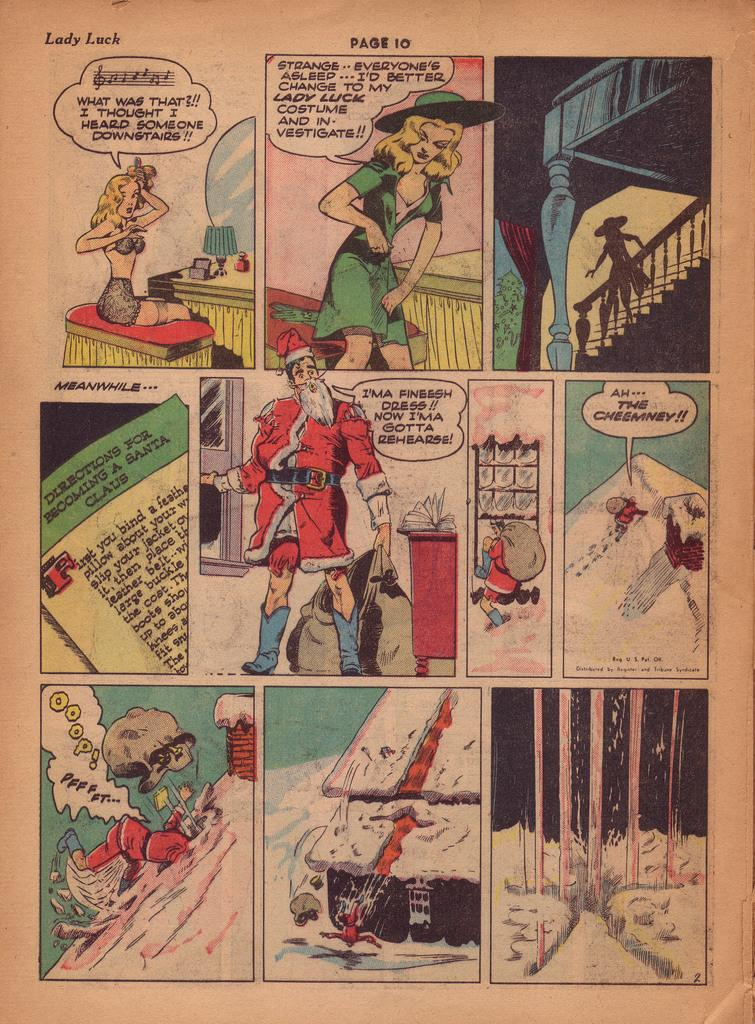Provide a one-sentence caption for the provided image. A Christmas themed comic book goes by the title Lady Luck. 